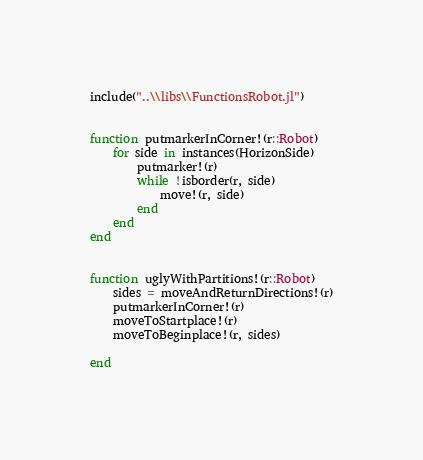<code> <loc_0><loc_0><loc_500><loc_500><_Julia_>include("..\\libs\\FunctionsRobot.jl")


function putmarkerInCorner!(r::Robot)
    for side in instances(HorizonSide)
        putmarker!(r)
        while !isborder(r, side)
            move!(r, side)
        end
    end
end


function uglyWithPartitions!(r::Robot)
    sides = moveAndReturnDirections!(r)
    putmarkerInCorner!(r)
    moveToStartplace!(r)
    moveToBeginplace!(r, sides)
    
end

</code> 